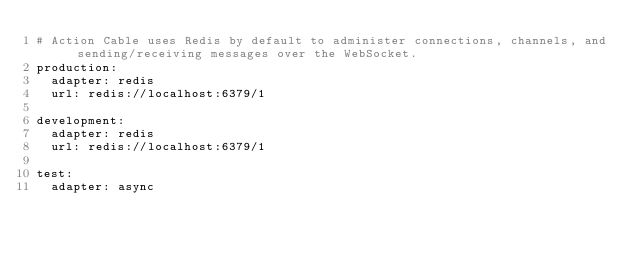Convert code to text. <code><loc_0><loc_0><loc_500><loc_500><_YAML_># Action Cable uses Redis by default to administer connections, channels, and sending/receiving messages over the WebSocket.
production:
  adapter: redis
  url: redis://localhost:6379/1

development:
  adapter: redis
  url: redis://localhost:6379/1

test:
  adapter: async
</code> 